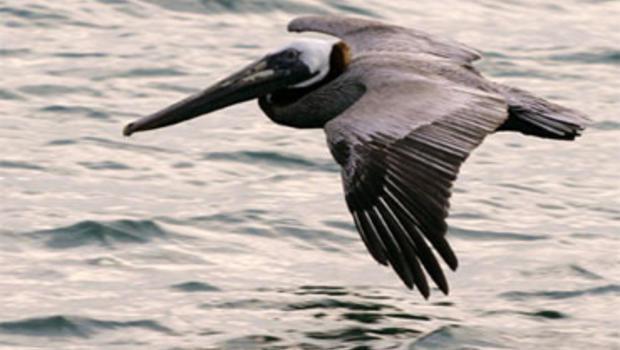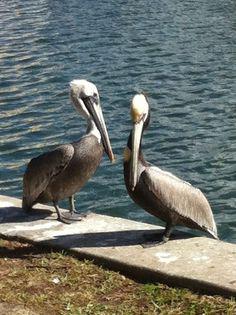The first image is the image on the left, the second image is the image on the right. Examine the images to the left and right. Is the description "There is no more than two birds in the left image." accurate? Answer yes or no. Yes. The first image is the image on the left, the second image is the image on the right. Considering the images on both sides, is "All pelicans are on the water, one image contains exactly two pelicans, and each image contains no more than three pelicans." valid? Answer yes or no. No. 